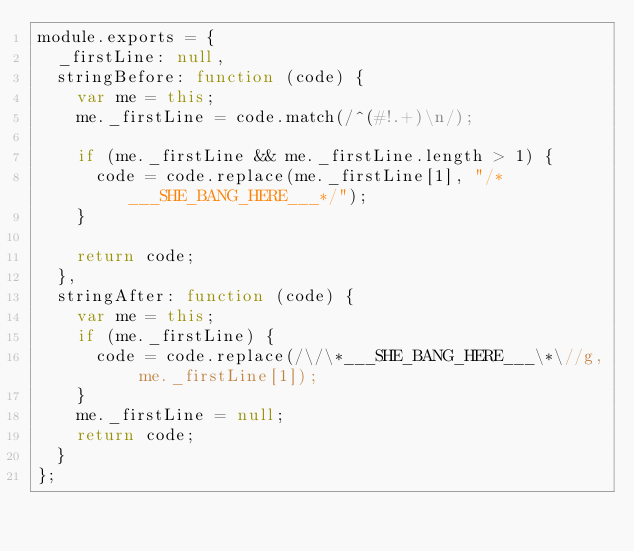<code> <loc_0><loc_0><loc_500><loc_500><_JavaScript_>module.exports = {
  _firstLine: null,
  stringBefore: function (code) {
    var me = this;
    me._firstLine = code.match(/^(#!.+)\n/);

    if (me._firstLine && me._firstLine.length > 1) {
      code = code.replace(me._firstLine[1], "/*___SHE_BANG_HERE___*/");
    }

    return code;
  },
  stringAfter: function (code) {
    var me = this;
    if (me._firstLine) {
      code = code.replace(/\/\*___SHE_BANG_HERE___\*\//g, me._firstLine[1]);
    }
    me._firstLine = null;
    return code;
  }
};
</code> 